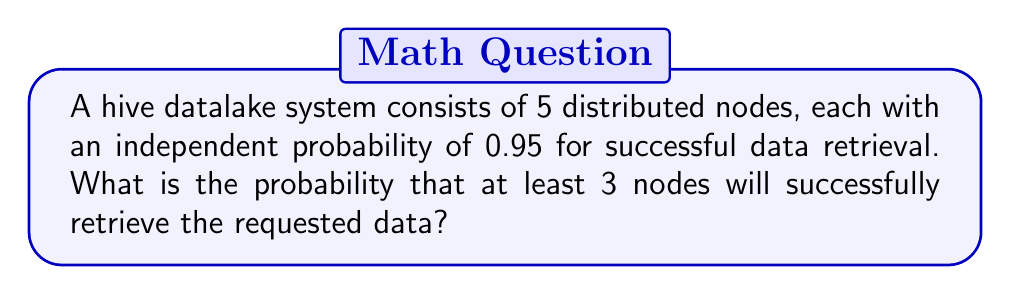Can you answer this question? Let's approach this step-by-step:

1) This is a binomial probability problem. We need to find the probability of at least 3 successes out of 5 trials.

2) Let's define our variables:
   $n = 5$ (total number of nodes)
   $p = 0.95$ (probability of success for each node)
   $q = 1 - p = 0.05$ (probability of failure for each node)

3) We need to calculate P(X ≥ 3), where X is the number of successful retrievals.

4) This is equivalent to 1 - P(X < 3) = 1 - [P(X = 0) + P(X = 1) + P(X = 2)]

5) We can use the binomial probability formula:

   $$P(X = k) = \binom{n}{k} p^k q^{n-k}$$

6) Let's calculate each probability:

   P(X = 0) = $\binom{5}{0} (0.95)^0 (0.05)^5 = 3.125 \times 10^{-7}$
   
   P(X = 1) = $\binom{5}{1} (0.95)^1 (0.05)^4 = 2.96875 \times 10^{-5}$
   
   P(X = 2) = $\binom{5}{2} (0.95)^2 (0.05)^3 = 0.001128125$

7) Sum these probabilities:
   
   P(X < 3) = $3.125 \times 10^{-7} + 2.96875 \times 10^{-5} + 0.001128125 = 0.001157788$

8) Therefore, P(X ≥ 3) = 1 - 0.001157788 = 0.998842212
Answer: 0.998842212 